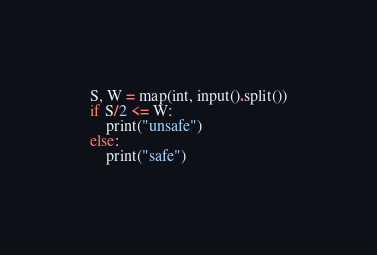Convert code to text. <code><loc_0><loc_0><loc_500><loc_500><_Python_>S, W = map(int, input().split())
if S/2 <= W: 
    print("unsafe")
else:
    print("safe")
</code> 